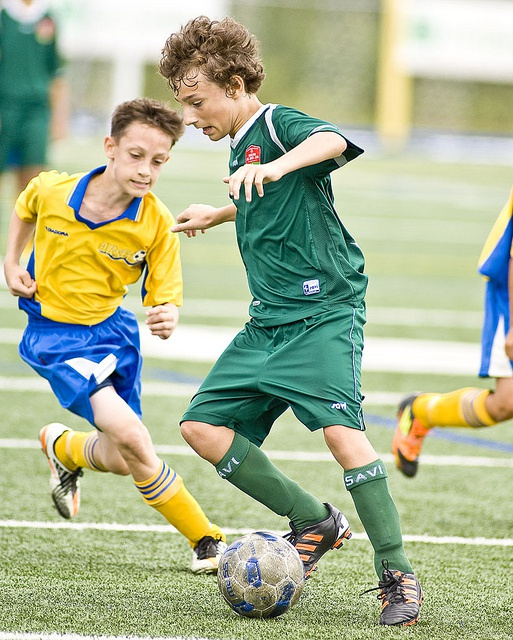Describe the objects in this image and their specific colors. I can see people in darkgray, teal, black, and ivory tones, people in darkgray, khaki, ivory, and gold tones, people in darkgray, khaki, white, blue, and tan tones, people in darkgray, teal, and tan tones, and sports ball in darkgray, lightgray, tan, and beige tones in this image. 